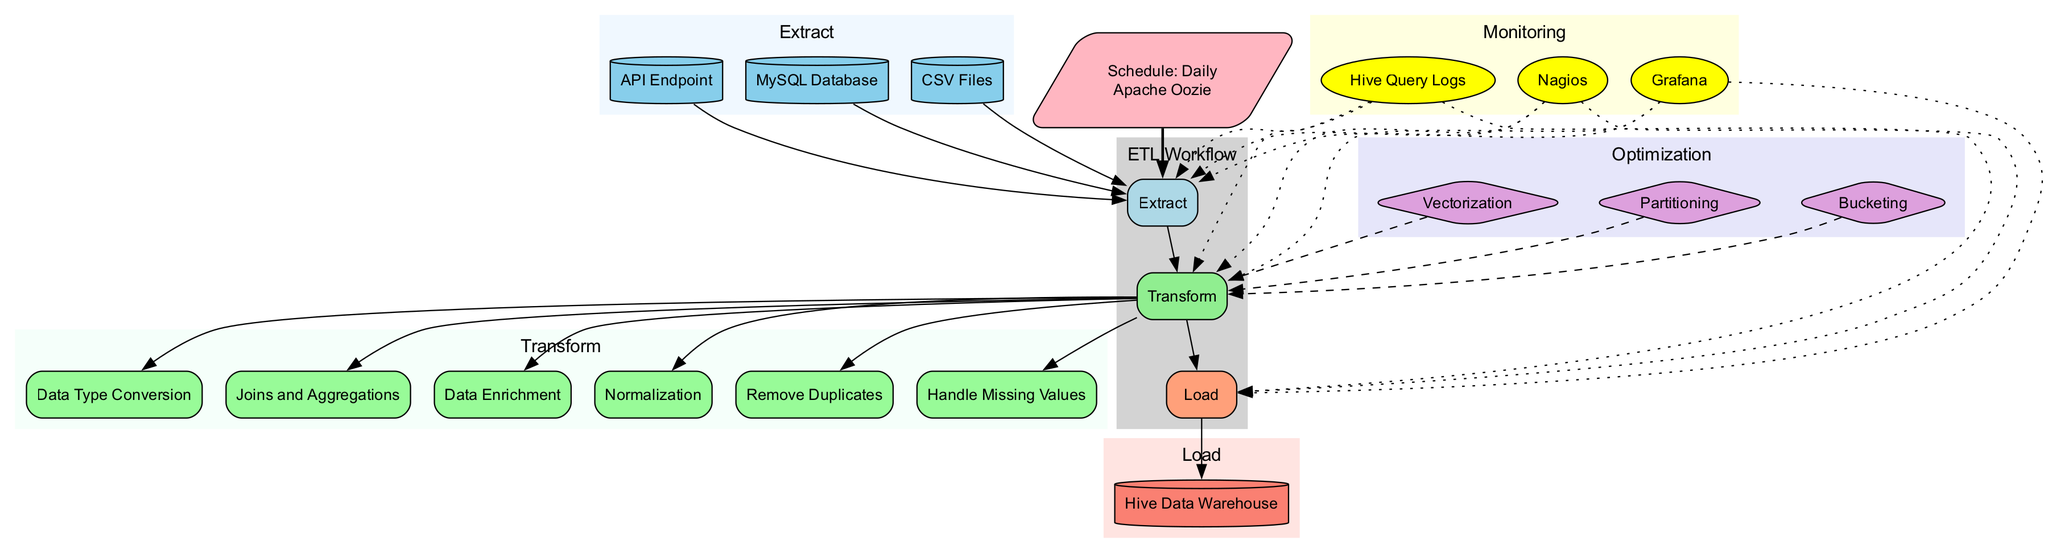What are the data sources listed in the Extract stage? In the Extract stage, there are three specified data sources including MySQL Database, CSV Files, and API Endpoint. These are indicated as inputs directly connected to the Extract node in the diagram.
Answer: MySQL Database, CSV Files, API Endpoint How many data cleaning processes are defined in the Transform stage? The Transform stage includes three data cleaning processes, which are Remove Duplicates, Handle Missing Values, and Data Type Conversion. This total is derived by counting the individual processes listed under the DataCleaning subcategory.
Answer: 3 What is the destination of the Load stage? The Load stage has the destination explicitly stated as the Hive Data Warehouse. This information is directly labeled as the output of the Load node in the diagram.
Answer: Hive Data Warehouse Which scheduling tool is used in this ETL Workflow? The scheduling tool specified for this ETL Workflow is Apache Oozie, mentioned alongside the frequency of execution which is daily. Both pieces of information are presented within the scheduling node.
Answer: Apache Oozie How many optimization techniques are shown in the Optimization section? There are three optimization techniques listed in the Optimization section, which include Partitioning, Bucketing, and Vectorization. Counting these techniques leads to this total.
Answer: 3 What is the relationship between the Monitoring tools and the Extract, Transform, and Load stages? The Monitoring tools have a dotted line connection to each of the Extract, Transform, and Load stages, indicating that these tools monitor the performance and metrics of all three stages simultaneously. Thus, they provide oversight across the entire ETL process.
Answer: Dotted connections to all stages Which tool is used for monitoring job success rate? In the Monitoring section, Nagios is one of the tools included, which is typically used to monitor system metrics like job success rate, as reflected by its role represented in the diagram.
Answer: Nagios What is the frequency of the schedule for the ETL Workflow? The frequency of the schedule is noted as Daily, which is presented in the scheduling node alongside the associated scheduling tool in the diagram.
Answer: Daily What type of data fetching method is associated with API endpoints in the Extract stage? The method associated with fetching data from API endpoints in the Extract stage is labeled API Data Fetching. This specific method is directly linked to the extraction process in the diagram.
Answer: API Data Fetching 